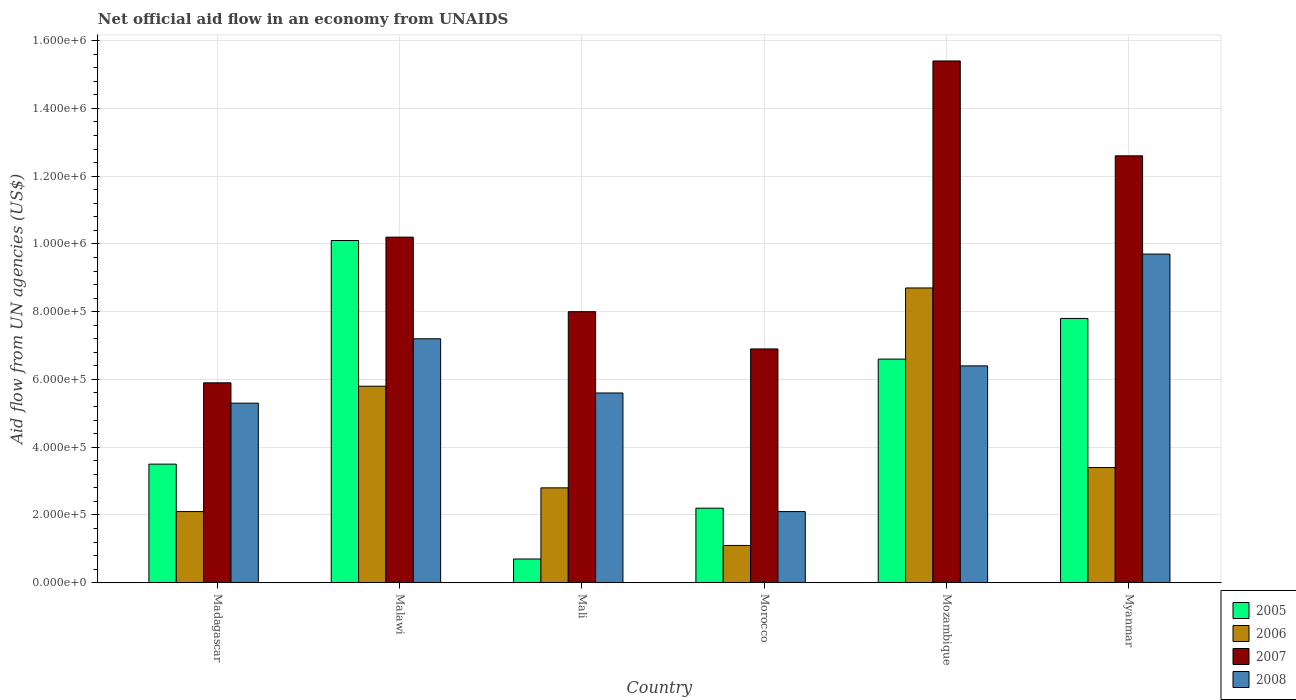How many different coloured bars are there?
Provide a short and direct response. 4. Are the number of bars on each tick of the X-axis equal?
Give a very brief answer. Yes. How many bars are there on the 5th tick from the left?
Provide a succinct answer. 4. What is the label of the 3rd group of bars from the left?
Ensure brevity in your answer.  Mali. What is the net official aid flow in 2006 in Malawi?
Give a very brief answer. 5.80e+05. Across all countries, what is the maximum net official aid flow in 2007?
Your response must be concise. 1.54e+06. Across all countries, what is the minimum net official aid flow in 2006?
Your answer should be compact. 1.10e+05. In which country was the net official aid flow in 2008 maximum?
Your response must be concise. Myanmar. In which country was the net official aid flow in 2005 minimum?
Provide a succinct answer. Mali. What is the total net official aid flow in 2006 in the graph?
Provide a succinct answer. 2.39e+06. What is the difference between the net official aid flow in 2006 in Mali and that in Mozambique?
Make the answer very short. -5.90e+05. What is the average net official aid flow in 2005 per country?
Your response must be concise. 5.15e+05. What is the difference between the net official aid flow of/in 2007 and net official aid flow of/in 2005 in Morocco?
Ensure brevity in your answer.  4.70e+05. What is the ratio of the net official aid flow in 2006 in Mozambique to that in Myanmar?
Your response must be concise. 2.56. What is the difference between the highest and the lowest net official aid flow in 2007?
Provide a short and direct response. 9.50e+05. What does the 1st bar from the left in Mozambique represents?
Provide a succinct answer. 2005. What does the 3rd bar from the right in Malawi represents?
Make the answer very short. 2006. Is it the case that in every country, the sum of the net official aid flow in 2008 and net official aid flow in 2006 is greater than the net official aid flow in 2005?
Give a very brief answer. Yes. What is the difference between two consecutive major ticks on the Y-axis?
Make the answer very short. 2.00e+05. Does the graph contain any zero values?
Your answer should be compact. No. What is the title of the graph?
Ensure brevity in your answer.  Net official aid flow in an economy from UNAIDS. What is the label or title of the X-axis?
Offer a very short reply. Country. What is the label or title of the Y-axis?
Provide a short and direct response. Aid flow from UN agencies (US$). What is the Aid flow from UN agencies (US$) in 2007 in Madagascar?
Provide a succinct answer. 5.90e+05. What is the Aid flow from UN agencies (US$) in 2008 in Madagascar?
Your response must be concise. 5.30e+05. What is the Aid flow from UN agencies (US$) in 2005 in Malawi?
Make the answer very short. 1.01e+06. What is the Aid flow from UN agencies (US$) in 2006 in Malawi?
Give a very brief answer. 5.80e+05. What is the Aid flow from UN agencies (US$) of 2007 in Malawi?
Provide a short and direct response. 1.02e+06. What is the Aid flow from UN agencies (US$) in 2008 in Malawi?
Your answer should be very brief. 7.20e+05. What is the Aid flow from UN agencies (US$) in 2007 in Mali?
Keep it short and to the point. 8.00e+05. What is the Aid flow from UN agencies (US$) of 2008 in Mali?
Your answer should be compact. 5.60e+05. What is the Aid flow from UN agencies (US$) of 2005 in Morocco?
Offer a very short reply. 2.20e+05. What is the Aid flow from UN agencies (US$) in 2006 in Morocco?
Provide a short and direct response. 1.10e+05. What is the Aid flow from UN agencies (US$) of 2007 in Morocco?
Your answer should be very brief. 6.90e+05. What is the Aid flow from UN agencies (US$) of 2005 in Mozambique?
Keep it short and to the point. 6.60e+05. What is the Aid flow from UN agencies (US$) in 2006 in Mozambique?
Give a very brief answer. 8.70e+05. What is the Aid flow from UN agencies (US$) of 2007 in Mozambique?
Your answer should be compact. 1.54e+06. What is the Aid flow from UN agencies (US$) in 2008 in Mozambique?
Offer a very short reply. 6.40e+05. What is the Aid flow from UN agencies (US$) in 2005 in Myanmar?
Your answer should be compact. 7.80e+05. What is the Aid flow from UN agencies (US$) of 2007 in Myanmar?
Give a very brief answer. 1.26e+06. What is the Aid flow from UN agencies (US$) of 2008 in Myanmar?
Offer a terse response. 9.70e+05. Across all countries, what is the maximum Aid flow from UN agencies (US$) in 2005?
Provide a succinct answer. 1.01e+06. Across all countries, what is the maximum Aid flow from UN agencies (US$) of 2006?
Your answer should be compact. 8.70e+05. Across all countries, what is the maximum Aid flow from UN agencies (US$) of 2007?
Keep it short and to the point. 1.54e+06. Across all countries, what is the maximum Aid flow from UN agencies (US$) in 2008?
Make the answer very short. 9.70e+05. Across all countries, what is the minimum Aid flow from UN agencies (US$) of 2005?
Offer a terse response. 7.00e+04. Across all countries, what is the minimum Aid flow from UN agencies (US$) in 2006?
Offer a terse response. 1.10e+05. Across all countries, what is the minimum Aid flow from UN agencies (US$) of 2007?
Make the answer very short. 5.90e+05. What is the total Aid flow from UN agencies (US$) in 2005 in the graph?
Offer a very short reply. 3.09e+06. What is the total Aid flow from UN agencies (US$) of 2006 in the graph?
Ensure brevity in your answer.  2.39e+06. What is the total Aid flow from UN agencies (US$) in 2007 in the graph?
Your answer should be very brief. 5.90e+06. What is the total Aid flow from UN agencies (US$) of 2008 in the graph?
Provide a short and direct response. 3.63e+06. What is the difference between the Aid flow from UN agencies (US$) of 2005 in Madagascar and that in Malawi?
Offer a terse response. -6.60e+05. What is the difference between the Aid flow from UN agencies (US$) in 2006 in Madagascar and that in Malawi?
Your answer should be very brief. -3.70e+05. What is the difference between the Aid flow from UN agencies (US$) of 2007 in Madagascar and that in Malawi?
Give a very brief answer. -4.30e+05. What is the difference between the Aid flow from UN agencies (US$) in 2008 in Madagascar and that in Malawi?
Keep it short and to the point. -1.90e+05. What is the difference between the Aid flow from UN agencies (US$) in 2005 in Madagascar and that in Mali?
Offer a terse response. 2.80e+05. What is the difference between the Aid flow from UN agencies (US$) in 2006 in Madagascar and that in Mali?
Your answer should be very brief. -7.00e+04. What is the difference between the Aid flow from UN agencies (US$) in 2005 in Madagascar and that in Morocco?
Your answer should be compact. 1.30e+05. What is the difference between the Aid flow from UN agencies (US$) in 2008 in Madagascar and that in Morocco?
Make the answer very short. 3.20e+05. What is the difference between the Aid flow from UN agencies (US$) of 2005 in Madagascar and that in Mozambique?
Provide a succinct answer. -3.10e+05. What is the difference between the Aid flow from UN agencies (US$) in 2006 in Madagascar and that in Mozambique?
Provide a short and direct response. -6.60e+05. What is the difference between the Aid flow from UN agencies (US$) in 2007 in Madagascar and that in Mozambique?
Offer a terse response. -9.50e+05. What is the difference between the Aid flow from UN agencies (US$) in 2005 in Madagascar and that in Myanmar?
Give a very brief answer. -4.30e+05. What is the difference between the Aid flow from UN agencies (US$) in 2006 in Madagascar and that in Myanmar?
Ensure brevity in your answer.  -1.30e+05. What is the difference between the Aid flow from UN agencies (US$) in 2007 in Madagascar and that in Myanmar?
Ensure brevity in your answer.  -6.70e+05. What is the difference between the Aid flow from UN agencies (US$) of 2008 in Madagascar and that in Myanmar?
Give a very brief answer. -4.40e+05. What is the difference between the Aid flow from UN agencies (US$) of 2005 in Malawi and that in Mali?
Offer a very short reply. 9.40e+05. What is the difference between the Aid flow from UN agencies (US$) in 2007 in Malawi and that in Mali?
Offer a terse response. 2.20e+05. What is the difference between the Aid flow from UN agencies (US$) of 2005 in Malawi and that in Morocco?
Provide a succinct answer. 7.90e+05. What is the difference between the Aid flow from UN agencies (US$) in 2006 in Malawi and that in Morocco?
Keep it short and to the point. 4.70e+05. What is the difference between the Aid flow from UN agencies (US$) of 2007 in Malawi and that in Morocco?
Keep it short and to the point. 3.30e+05. What is the difference between the Aid flow from UN agencies (US$) in 2008 in Malawi and that in Morocco?
Make the answer very short. 5.10e+05. What is the difference between the Aid flow from UN agencies (US$) in 2006 in Malawi and that in Mozambique?
Give a very brief answer. -2.90e+05. What is the difference between the Aid flow from UN agencies (US$) in 2007 in Malawi and that in Mozambique?
Provide a succinct answer. -5.20e+05. What is the difference between the Aid flow from UN agencies (US$) in 2005 in Malawi and that in Myanmar?
Offer a very short reply. 2.30e+05. What is the difference between the Aid flow from UN agencies (US$) of 2006 in Malawi and that in Myanmar?
Your answer should be very brief. 2.40e+05. What is the difference between the Aid flow from UN agencies (US$) in 2007 in Mali and that in Morocco?
Offer a very short reply. 1.10e+05. What is the difference between the Aid flow from UN agencies (US$) in 2008 in Mali and that in Morocco?
Your response must be concise. 3.50e+05. What is the difference between the Aid flow from UN agencies (US$) in 2005 in Mali and that in Mozambique?
Offer a very short reply. -5.90e+05. What is the difference between the Aid flow from UN agencies (US$) in 2006 in Mali and that in Mozambique?
Keep it short and to the point. -5.90e+05. What is the difference between the Aid flow from UN agencies (US$) of 2007 in Mali and that in Mozambique?
Ensure brevity in your answer.  -7.40e+05. What is the difference between the Aid flow from UN agencies (US$) of 2008 in Mali and that in Mozambique?
Your answer should be compact. -8.00e+04. What is the difference between the Aid flow from UN agencies (US$) in 2005 in Mali and that in Myanmar?
Your answer should be compact. -7.10e+05. What is the difference between the Aid flow from UN agencies (US$) of 2007 in Mali and that in Myanmar?
Provide a succinct answer. -4.60e+05. What is the difference between the Aid flow from UN agencies (US$) of 2008 in Mali and that in Myanmar?
Your answer should be compact. -4.10e+05. What is the difference between the Aid flow from UN agencies (US$) in 2005 in Morocco and that in Mozambique?
Your answer should be compact. -4.40e+05. What is the difference between the Aid flow from UN agencies (US$) of 2006 in Morocco and that in Mozambique?
Your answer should be very brief. -7.60e+05. What is the difference between the Aid flow from UN agencies (US$) of 2007 in Morocco and that in Mozambique?
Offer a very short reply. -8.50e+05. What is the difference between the Aid flow from UN agencies (US$) in 2008 in Morocco and that in Mozambique?
Provide a short and direct response. -4.30e+05. What is the difference between the Aid flow from UN agencies (US$) in 2005 in Morocco and that in Myanmar?
Give a very brief answer. -5.60e+05. What is the difference between the Aid flow from UN agencies (US$) in 2006 in Morocco and that in Myanmar?
Give a very brief answer. -2.30e+05. What is the difference between the Aid flow from UN agencies (US$) in 2007 in Morocco and that in Myanmar?
Your response must be concise. -5.70e+05. What is the difference between the Aid flow from UN agencies (US$) of 2008 in Morocco and that in Myanmar?
Provide a short and direct response. -7.60e+05. What is the difference between the Aid flow from UN agencies (US$) in 2005 in Mozambique and that in Myanmar?
Make the answer very short. -1.20e+05. What is the difference between the Aid flow from UN agencies (US$) in 2006 in Mozambique and that in Myanmar?
Keep it short and to the point. 5.30e+05. What is the difference between the Aid flow from UN agencies (US$) in 2008 in Mozambique and that in Myanmar?
Provide a succinct answer. -3.30e+05. What is the difference between the Aid flow from UN agencies (US$) in 2005 in Madagascar and the Aid flow from UN agencies (US$) in 2006 in Malawi?
Provide a short and direct response. -2.30e+05. What is the difference between the Aid flow from UN agencies (US$) in 2005 in Madagascar and the Aid flow from UN agencies (US$) in 2007 in Malawi?
Your response must be concise. -6.70e+05. What is the difference between the Aid flow from UN agencies (US$) of 2005 in Madagascar and the Aid flow from UN agencies (US$) of 2008 in Malawi?
Provide a short and direct response. -3.70e+05. What is the difference between the Aid flow from UN agencies (US$) of 2006 in Madagascar and the Aid flow from UN agencies (US$) of 2007 in Malawi?
Keep it short and to the point. -8.10e+05. What is the difference between the Aid flow from UN agencies (US$) in 2006 in Madagascar and the Aid flow from UN agencies (US$) in 2008 in Malawi?
Provide a succinct answer. -5.10e+05. What is the difference between the Aid flow from UN agencies (US$) in 2005 in Madagascar and the Aid flow from UN agencies (US$) in 2006 in Mali?
Provide a succinct answer. 7.00e+04. What is the difference between the Aid flow from UN agencies (US$) in 2005 in Madagascar and the Aid flow from UN agencies (US$) in 2007 in Mali?
Offer a very short reply. -4.50e+05. What is the difference between the Aid flow from UN agencies (US$) in 2006 in Madagascar and the Aid flow from UN agencies (US$) in 2007 in Mali?
Provide a succinct answer. -5.90e+05. What is the difference between the Aid flow from UN agencies (US$) in 2006 in Madagascar and the Aid flow from UN agencies (US$) in 2008 in Mali?
Ensure brevity in your answer.  -3.50e+05. What is the difference between the Aid flow from UN agencies (US$) of 2005 in Madagascar and the Aid flow from UN agencies (US$) of 2006 in Morocco?
Keep it short and to the point. 2.40e+05. What is the difference between the Aid flow from UN agencies (US$) in 2005 in Madagascar and the Aid flow from UN agencies (US$) in 2007 in Morocco?
Offer a terse response. -3.40e+05. What is the difference between the Aid flow from UN agencies (US$) of 2006 in Madagascar and the Aid flow from UN agencies (US$) of 2007 in Morocco?
Give a very brief answer. -4.80e+05. What is the difference between the Aid flow from UN agencies (US$) in 2005 in Madagascar and the Aid flow from UN agencies (US$) in 2006 in Mozambique?
Give a very brief answer. -5.20e+05. What is the difference between the Aid flow from UN agencies (US$) of 2005 in Madagascar and the Aid flow from UN agencies (US$) of 2007 in Mozambique?
Your response must be concise. -1.19e+06. What is the difference between the Aid flow from UN agencies (US$) of 2006 in Madagascar and the Aid flow from UN agencies (US$) of 2007 in Mozambique?
Offer a terse response. -1.33e+06. What is the difference between the Aid flow from UN agencies (US$) of 2006 in Madagascar and the Aid flow from UN agencies (US$) of 2008 in Mozambique?
Provide a short and direct response. -4.30e+05. What is the difference between the Aid flow from UN agencies (US$) of 2007 in Madagascar and the Aid flow from UN agencies (US$) of 2008 in Mozambique?
Provide a short and direct response. -5.00e+04. What is the difference between the Aid flow from UN agencies (US$) in 2005 in Madagascar and the Aid flow from UN agencies (US$) in 2006 in Myanmar?
Your answer should be compact. 10000. What is the difference between the Aid flow from UN agencies (US$) in 2005 in Madagascar and the Aid flow from UN agencies (US$) in 2007 in Myanmar?
Offer a terse response. -9.10e+05. What is the difference between the Aid flow from UN agencies (US$) of 2005 in Madagascar and the Aid flow from UN agencies (US$) of 2008 in Myanmar?
Ensure brevity in your answer.  -6.20e+05. What is the difference between the Aid flow from UN agencies (US$) of 2006 in Madagascar and the Aid flow from UN agencies (US$) of 2007 in Myanmar?
Make the answer very short. -1.05e+06. What is the difference between the Aid flow from UN agencies (US$) of 2006 in Madagascar and the Aid flow from UN agencies (US$) of 2008 in Myanmar?
Ensure brevity in your answer.  -7.60e+05. What is the difference between the Aid flow from UN agencies (US$) of 2007 in Madagascar and the Aid flow from UN agencies (US$) of 2008 in Myanmar?
Give a very brief answer. -3.80e+05. What is the difference between the Aid flow from UN agencies (US$) in 2005 in Malawi and the Aid flow from UN agencies (US$) in 2006 in Mali?
Your response must be concise. 7.30e+05. What is the difference between the Aid flow from UN agencies (US$) of 2005 in Malawi and the Aid flow from UN agencies (US$) of 2008 in Mali?
Provide a short and direct response. 4.50e+05. What is the difference between the Aid flow from UN agencies (US$) in 2006 in Malawi and the Aid flow from UN agencies (US$) in 2007 in Mali?
Your answer should be compact. -2.20e+05. What is the difference between the Aid flow from UN agencies (US$) of 2007 in Malawi and the Aid flow from UN agencies (US$) of 2008 in Mali?
Make the answer very short. 4.60e+05. What is the difference between the Aid flow from UN agencies (US$) in 2005 in Malawi and the Aid flow from UN agencies (US$) in 2007 in Morocco?
Offer a very short reply. 3.20e+05. What is the difference between the Aid flow from UN agencies (US$) of 2007 in Malawi and the Aid flow from UN agencies (US$) of 2008 in Morocco?
Keep it short and to the point. 8.10e+05. What is the difference between the Aid flow from UN agencies (US$) in 2005 in Malawi and the Aid flow from UN agencies (US$) in 2007 in Mozambique?
Offer a terse response. -5.30e+05. What is the difference between the Aid flow from UN agencies (US$) in 2005 in Malawi and the Aid flow from UN agencies (US$) in 2008 in Mozambique?
Your response must be concise. 3.70e+05. What is the difference between the Aid flow from UN agencies (US$) in 2006 in Malawi and the Aid flow from UN agencies (US$) in 2007 in Mozambique?
Offer a terse response. -9.60e+05. What is the difference between the Aid flow from UN agencies (US$) of 2007 in Malawi and the Aid flow from UN agencies (US$) of 2008 in Mozambique?
Your response must be concise. 3.80e+05. What is the difference between the Aid flow from UN agencies (US$) in 2005 in Malawi and the Aid flow from UN agencies (US$) in 2006 in Myanmar?
Your answer should be very brief. 6.70e+05. What is the difference between the Aid flow from UN agencies (US$) of 2005 in Malawi and the Aid flow from UN agencies (US$) of 2007 in Myanmar?
Offer a very short reply. -2.50e+05. What is the difference between the Aid flow from UN agencies (US$) of 2005 in Malawi and the Aid flow from UN agencies (US$) of 2008 in Myanmar?
Your answer should be very brief. 4.00e+04. What is the difference between the Aid flow from UN agencies (US$) in 2006 in Malawi and the Aid flow from UN agencies (US$) in 2007 in Myanmar?
Your answer should be very brief. -6.80e+05. What is the difference between the Aid flow from UN agencies (US$) in 2006 in Malawi and the Aid flow from UN agencies (US$) in 2008 in Myanmar?
Your answer should be very brief. -3.90e+05. What is the difference between the Aid flow from UN agencies (US$) in 2005 in Mali and the Aid flow from UN agencies (US$) in 2006 in Morocco?
Make the answer very short. -4.00e+04. What is the difference between the Aid flow from UN agencies (US$) in 2005 in Mali and the Aid flow from UN agencies (US$) in 2007 in Morocco?
Offer a very short reply. -6.20e+05. What is the difference between the Aid flow from UN agencies (US$) in 2006 in Mali and the Aid flow from UN agencies (US$) in 2007 in Morocco?
Keep it short and to the point. -4.10e+05. What is the difference between the Aid flow from UN agencies (US$) of 2007 in Mali and the Aid flow from UN agencies (US$) of 2008 in Morocco?
Ensure brevity in your answer.  5.90e+05. What is the difference between the Aid flow from UN agencies (US$) in 2005 in Mali and the Aid flow from UN agencies (US$) in 2006 in Mozambique?
Your answer should be compact. -8.00e+05. What is the difference between the Aid flow from UN agencies (US$) of 2005 in Mali and the Aid flow from UN agencies (US$) of 2007 in Mozambique?
Keep it short and to the point. -1.47e+06. What is the difference between the Aid flow from UN agencies (US$) in 2005 in Mali and the Aid flow from UN agencies (US$) in 2008 in Mozambique?
Your response must be concise. -5.70e+05. What is the difference between the Aid flow from UN agencies (US$) of 2006 in Mali and the Aid flow from UN agencies (US$) of 2007 in Mozambique?
Give a very brief answer. -1.26e+06. What is the difference between the Aid flow from UN agencies (US$) in 2006 in Mali and the Aid flow from UN agencies (US$) in 2008 in Mozambique?
Keep it short and to the point. -3.60e+05. What is the difference between the Aid flow from UN agencies (US$) of 2007 in Mali and the Aid flow from UN agencies (US$) of 2008 in Mozambique?
Make the answer very short. 1.60e+05. What is the difference between the Aid flow from UN agencies (US$) of 2005 in Mali and the Aid flow from UN agencies (US$) of 2007 in Myanmar?
Offer a very short reply. -1.19e+06. What is the difference between the Aid flow from UN agencies (US$) of 2005 in Mali and the Aid flow from UN agencies (US$) of 2008 in Myanmar?
Your response must be concise. -9.00e+05. What is the difference between the Aid flow from UN agencies (US$) in 2006 in Mali and the Aid flow from UN agencies (US$) in 2007 in Myanmar?
Ensure brevity in your answer.  -9.80e+05. What is the difference between the Aid flow from UN agencies (US$) of 2006 in Mali and the Aid flow from UN agencies (US$) of 2008 in Myanmar?
Ensure brevity in your answer.  -6.90e+05. What is the difference between the Aid flow from UN agencies (US$) in 2007 in Mali and the Aid flow from UN agencies (US$) in 2008 in Myanmar?
Provide a short and direct response. -1.70e+05. What is the difference between the Aid flow from UN agencies (US$) of 2005 in Morocco and the Aid flow from UN agencies (US$) of 2006 in Mozambique?
Provide a short and direct response. -6.50e+05. What is the difference between the Aid flow from UN agencies (US$) in 2005 in Morocco and the Aid flow from UN agencies (US$) in 2007 in Mozambique?
Give a very brief answer. -1.32e+06. What is the difference between the Aid flow from UN agencies (US$) in 2005 in Morocco and the Aid flow from UN agencies (US$) in 2008 in Mozambique?
Your response must be concise. -4.20e+05. What is the difference between the Aid flow from UN agencies (US$) of 2006 in Morocco and the Aid flow from UN agencies (US$) of 2007 in Mozambique?
Offer a very short reply. -1.43e+06. What is the difference between the Aid flow from UN agencies (US$) of 2006 in Morocco and the Aid flow from UN agencies (US$) of 2008 in Mozambique?
Give a very brief answer. -5.30e+05. What is the difference between the Aid flow from UN agencies (US$) of 2007 in Morocco and the Aid flow from UN agencies (US$) of 2008 in Mozambique?
Offer a terse response. 5.00e+04. What is the difference between the Aid flow from UN agencies (US$) in 2005 in Morocco and the Aid flow from UN agencies (US$) in 2007 in Myanmar?
Offer a terse response. -1.04e+06. What is the difference between the Aid flow from UN agencies (US$) in 2005 in Morocco and the Aid flow from UN agencies (US$) in 2008 in Myanmar?
Ensure brevity in your answer.  -7.50e+05. What is the difference between the Aid flow from UN agencies (US$) of 2006 in Morocco and the Aid flow from UN agencies (US$) of 2007 in Myanmar?
Ensure brevity in your answer.  -1.15e+06. What is the difference between the Aid flow from UN agencies (US$) of 2006 in Morocco and the Aid flow from UN agencies (US$) of 2008 in Myanmar?
Provide a short and direct response. -8.60e+05. What is the difference between the Aid flow from UN agencies (US$) of 2007 in Morocco and the Aid flow from UN agencies (US$) of 2008 in Myanmar?
Your response must be concise. -2.80e+05. What is the difference between the Aid flow from UN agencies (US$) in 2005 in Mozambique and the Aid flow from UN agencies (US$) in 2007 in Myanmar?
Ensure brevity in your answer.  -6.00e+05. What is the difference between the Aid flow from UN agencies (US$) of 2005 in Mozambique and the Aid flow from UN agencies (US$) of 2008 in Myanmar?
Make the answer very short. -3.10e+05. What is the difference between the Aid flow from UN agencies (US$) in 2006 in Mozambique and the Aid flow from UN agencies (US$) in 2007 in Myanmar?
Provide a short and direct response. -3.90e+05. What is the difference between the Aid flow from UN agencies (US$) of 2006 in Mozambique and the Aid flow from UN agencies (US$) of 2008 in Myanmar?
Ensure brevity in your answer.  -1.00e+05. What is the difference between the Aid flow from UN agencies (US$) in 2007 in Mozambique and the Aid flow from UN agencies (US$) in 2008 in Myanmar?
Offer a terse response. 5.70e+05. What is the average Aid flow from UN agencies (US$) in 2005 per country?
Ensure brevity in your answer.  5.15e+05. What is the average Aid flow from UN agencies (US$) in 2006 per country?
Provide a short and direct response. 3.98e+05. What is the average Aid flow from UN agencies (US$) in 2007 per country?
Give a very brief answer. 9.83e+05. What is the average Aid flow from UN agencies (US$) in 2008 per country?
Keep it short and to the point. 6.05e+05. What is the difference between the Aid flow from UN agencies (US$) of 2005 and Aid flow from UN agencies (US$) of 2008 in Madagascar?
Offer a very short reply. -1.80e+05. What is the difference between the Aid flow from UN agencies (US$) in 2006 and Aid flow from UN agencies (US$) in 2007 in Madagascar?
Your answer should be compact. -3.80e+05. What is the difference between the Aid flow from UN agencies (US$) of 2006 and Aid flow from UN agencies (US$) of 2008 in Madagascar?
Your answer should be compact. -3.20e+05. What is the difference between the Aid flow from UN agencies (US$) of 2006 and Aid flow from UN agencies (US$) of 2007 in Malawi?
Offer a very short reply. -4.40e+05. What is the difference between the Aid flow from UN agencies (US$) in 2006 and Aid flow from UN agencies (US$) in 2008 in Malawi?
Provide a short and direct response. -1.40e+05. What is the difference between the Aid flow from UN agencies (US$) of 2007 and Aid flow from UN agencies (US$) of 2008 in Malawi?
Your response must be concise. 3.00e+05. What is the difference between the Aid flow from UN agencies (US$) of 2005 and Aid flow from UN agencies (US$) of 2007 in Mali?
Provide a succinct answer. -7.30e+05. What is the difference between the Aid flow from UN agencies (US$) in 2005 and Aid flow from UN agencies (US$) in 2008 in Mali?
Your answer should be very brief. -4.90e+05. What is the difference between the Aid flow from UN agencies (US$) in 2006 and Aid flow from UN agencies (US$) in 2007 in Mali?
Offer a terse response. -5.20e+05. What is the difference between the Aid flow from UN agencies (US$) of 2006 and Aid flow from UN agencies (US$) of 2008 in Mali?
Your response must be concise. -2.80e+05. What is the difference between the Aid flow from UN agencies (US$) of 2005 and Aid flow from UN agencies (US$) of 2007 in Morocco?
Provide a succinct answer. -4.70e+05. What is the difference between the Aid flow from UN agencies (US$) in 2005 and Aid flow from UN agencies (US$) in 2008 in Morocco?
Your response must be concise. 10000. What is the difference between the Aid flow from UN agencies (US$) in 2006 and Aid flow from UN agencies (US$) in 2007 in Morocco?
Provide a short and direct response. -5.80e+05. What is the difference between the Aid flow from UN agencies (US$) in 2006 and Aid flow from UN agencies (US$) in 2008 in Morocco?
Your response must be concise. -1.00e+05. What is the difference between the Aid flow from UN agencies (US$) of 2005 and Aid flow from UN agencies (US$) of 2007 in Mozambique?
Your answer should be compact. -8.80e+05. What is the difference between the Aid flow from UN agencies (US$) in 2005 and Aid flow from UN agencies (US$) in 2008 in Mozambique?
Your answer should be compact. 2.00e+04. What is the difference between the Aid flow from UN agencies (US$) in 2006 and Aid flow from UN agencies (US$) in 2007 in Mozambique?
Your answer should be compact. -6.70e+05. What is the difference between the Aid flow from UN agencies (US$) in 2006 and Aid flow from UN agencies (US$) in 2008 in Mozambique?
Offer a terse response. 2.30e+05. What is the difference between the Aid flow from UN agencies (US$) of 2005 and Aid flow from UN agencies (US$) of 2007 in Myanmar?
Your answer should be very brief. -4.80e+05. What is the difference between the Aid flow from UN agencies (US$) in 2005 and Aid flow from UN agencies (US$) in 2008 in Myanmar?
Your answer should be very brief. -1.90e+05. What is the difference between the Aid flow from UN agencies (US$) of 2006 and Aid flow from UN agencies (US$) of 2007 in Myanmar?
Offer a terse response. -9.20e+05. What is the difference between the Aid flow from UN agencies (US$) in 2006 and Aid flow from UN agencies (US$) in 2008 in Myanmar?
Keep it short and to the point. -6.30e+05. What is the ratio of the Aid flow from UN agencies (US$) of 2005 in Madagascar to that in Malawi?
Your response must be concise. 0.35. What is the ratio of the Aid flow from UN agencies (US$) in 2006 in Madagascar to that in Malawi?
Your answer should be very brief. 0.36. What is the ratio of the Aid flow from UN agencies (US$) in 2007 in Madagascar to that in Malawi?
Your answer should be compact. 0.58. What is the ratio of the Aid flow from UN agencies (US$) of 2008 in Madagascar to that in Malawi?
Provide a succinct answer. 0.74. What is the ratio of the Aid flow from UN agencies (US$) in 2007 in Madagascar to that in Mali?
Offer a very short reply. 0.74. What is the ratio of the Aid flow from UN agencies (US$) of 2008 in Madagascar to that in Mali?
Your answer should be very brief. 0.95. What is the ratio of the Aid flow from UN agencies (US$) of 2005 in Madagascar to that in Morocco?
Provide a short and direct response. 1.59. What is the ratio of the Aid flow from UN agencies (US$) in 2006 in Madagascar to that in Morocco?
Your answer should be very brief. 1.91. What is the ratio of the Aid flow from UN agencies (US$) in 2007 in Madagascar to that in Morocco?
Keep it short and to the point. 0.86. What is the ratio of the Aid flow from UN agencies (US$) of 2008 in Madagascar to that in Morocco?
Make the answer very short. 2.52. What is the ratio of the Aid flow from UN agencies (US$) of 2005 in Madagascar to that in Mozambique?
Keep it short and to the point. 0.53. What is the ratio of the Aid flow from UN agencies (US$) in 2006 in Madagascar to that in Mozambique?
Ensure brevity in your answer.  0.24. What is the ratio of the Aid flow from UN agencies (US$) of 2007 in Madagascar to that in Mozambique?
Provide a short and direct response. 0.38. What is the ratio of the Aid flow from UN agencies (US$) of 2008 in Madagascar to that in Mozambique?
Make the answer very short. 0.83. What is the ratio of the Aid flow from UN agencies (US$) in 2005 in Madagascar to that in Myanmar?
Provide a succinct answer. 0.45. What is the ratio of the Aid flow from UN agencies (US$) in 2006 in Madagascar to that in Myanmar?
Your answer should be very brief. 0.62. What is the ratio of the Aid flow from UN agencies (US$) in 2007 in Madagascar to that in Myanmar?
Offer a very short reply. 0.47. What is the ratio of the Aid flow from UN agencies (US$) of 2008 in Madagascar to that in Myanmar?
Ensure brevity in your answer.  0.55. What is the ratio of the Aid flow from UN agencies (US$) in 2005 in Malawi to that in Mali?
Make the answer very short. 14.43. What is the ratio of the Aid flow from UN agencies (US$) of 2006 in Malawi to that in Mali?
Your response must be concise. 2.07. What is the ratio of the Aid flow from UN agencies (US$) of 2007 in Malawi to that in Mali?
Give a very brief answer. 1.27. What is the ratio of the Aid flow from UN agencies (US$) in 2008 in Malawi to that in Mali?
Your answer should be compact. 1.29. What is the ratio of the Aid flow from UN agencies (US$) of 2005 in Malawi to that in Morocco?
Provide a succinct answer. 4.59. What is the ratio of the Aid flow from UN agencies (US$) of 2006 in Malawi to that in Morocco?
Provide a short and direct response. 5.27. What is the ratio of the Aid flow from UN agencies (US$) of 2007 in Malawi to that in Morocco?
Provide a short and direct response. 1.48. What is the ratio of the Aid flow from UN agencies (US$) of 2008 in Malawi to that in Morocco?
Give a very brief answer. 3.43. What is the ratio of the Aid flow from UN agencies (US$) of 2005 in Malawi to that in Mozambique?
Your answer should be compact. 1.53. What is the ratio of the Aid flow from UN agencies (US$) in 2006 in Malawi to that in Mozambique?
Offer a very short reply. 0.67. What is the ratio of the Aid flow from UN agencies (US$) in 2007 in Malawi to that in Mozambique?
Keep it short and to the point. 0.66. What is the ratio of the Aid flow from UN agencies (US$) of 2008 in Malawi to that in Mozambique?
Give a very brief answer. 1.12. What is the ratio of the Aid flow from UN agencies (US$) in 2005 in Malawi to that in Myanmar?
Your response must be concise. 1.29. What is the ratio of the Aid flow from UN agencies (US$) in 2006 in Malawi to that in Myanmar?
Give a very brief answer. 1.71. What is the ratio of the Aid flow from UN agencies (US$) in 2007 in Malawi to that in Myanmar?
Make the answer very short. 0.81. What is the ratio of the Aid flow from UN agencies (US$) of 2008 in Malawi to that in Myanmar?
Make the answer very short. 0.74. What is the ratio of the Aid flow from UN agencies (US$) in 2005 in Mali to that in Morocco?
Give a very brief answer. 0.32. What is the ratio of the Aid flow from UN agencies (US$) in 2006 in Mali to that in Morocco?
Give a very brief answer. 2.55. What is the ratio of the Aid flow from UN agencies (US$) of 2007 in Mali to that in Morocco?
Offer a very short reply. 1.16. What is the ratio of the Aid flow from UN agencies (US$) in 2008 in Mali to that in Morocco?
Your answer should be compact. 2.67. What is the ratio of the Aid flow from UN agencies (US$) in 2005 in Mali to that in Mozambique?
Ensure brevity in your answer.  0.11. What is the ratio of the Aid flow from UN agencies (US$) in 2006 in Mali to that in Mozambique?
Offer a very short reply. 0.32. What is the ratio of the Aid flow from UN agencies (US$) in 2007 in Mali to that in Mozambique?
Make the answer very short. 0.52. What is the ratio of the Aid flow from UN agencies (US$) of 2008 in Mali to that in Mozambique?
Provide a succinct answer. 0.88. What is the ratio of the Aid flow from UN agencies (US$) in 2005 in Mali to that in Myanmar?
Provide a succinct answer. 0.09. What is the ratio of the Aid flow from UN agencies (US$) in 2006 in Mali to that in Myanmar?
Your answer should be compact. 0.82. What is the ratio of the Aid flow from UN agencies (US$) of 2007 in Mali to that in Myanmar?
Give a very brief answer. 0.63. What is the ratio of the Aid flow from UN agencies (US$) of 2008 in Mali to that in Myanmar?
Your answer should be compact. 0.58. What is the ratio of the Aid flow from UN agencies (US$) of 2005 in Morocco to that in Mozambique?
Offer a terse response. 0.33. What is the ratio of the Aid flow from UN agencies (US$) of 2006 in Morocco to that in Mozambique?
Make the answer very short. 0.13. What is the ratio of the Aid flow from UN agencies (US$) of 2007 in Morocco to that in Mozambique?
Your answer should be very brief. 0.45. What is the ratio of the Aid flow from UN agencies (US$) of 2008 in Morocco to that in Mozambique?
Ensure brevity in your answer.  0.33. What is the ratio of the Aid flow from UN agencies (US$) in 2005 in Morocco to that in Myanmar?
Provide a short and direct response. 0.28. What is the ratio of the Aid flow from UN agencies (US$) of 2006 in Morocco to that in Myanmar?
Your answer should be compact. 0.32. What is the ratio of the Aid flow from UN agencies (US$) in 2007 in Morocco to that in Myanmar?
Give a very brief answer. 0.55. What is the ratio of the Aid flow from UN agencies (US$) of 2008 in Morocco to that in Myanmar?
Make the answer very short. 0.22. What is the ratio of the Aid flow from UN agencies (US$) in 2005 in Mozambique to that in Myanmar?
Your answer should be compact. 0.85. What is the ratio of the Aid flow from UN agencies (US$) of 2006 in Mozambique to that in Myanmar?
Ensure brevity in your answer.  2.56. What is the ratio of the Aid flow from UN agencies (US$) in 2007 in Mozambique to that in Myanmar?
Ensure brevity in your answer.  1.22. What is the ratio of the Aid flow from UN agencies (US$) of 2008 in Mozambique to that in Myanmar?
Your response must be concise. 0.66. What is the difference between the highest and the second highest Aid flow from UN agencies (US$) in 2005?
Your answer should be very brief. 2.30e+05. What is the difference between the highest and the second highest Aid flow from UN agencies (US$) of 2006?
Your answer should be very brief. 2.90e+05. What is the difference between the highest and the second highest Aid flow from UN agencies (US$) of 2007?
Provide a short and direct response. 2.80e+05. What is the difference between the highest and the second highest Aid flow from UN agencies (US$) of 2008?
Provide a short and direct response. 2.50e+05. What is the difference between the highest and the lowest Aid flow from UN agencies (US$) of 2005?
Provide a succinct answer. 9.40e+05. What is the difference between the highest and the lowest Aid flow from UN agencies (US$) of 2006?
Offer a terse response. 7.60e+05. What is the difference between the highest and the lowest Aid flow from UN agencies (US$) of 2007?
Ensure brevity in your answer.  9.50e+05. What is the difference between the highest and the lowest Aid flow from UN agencies (US$) in 2008?
Give a very brief answer. 7.60e+05. 